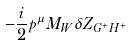Convert formula to latex. <formula><loc_0><loc_0><loc_500><loc_500>- \frac { i } { 2 } p ^ { \mu } M _ { W } \delta Z _ { G ^ { + } H ^ { + } }</formula> 